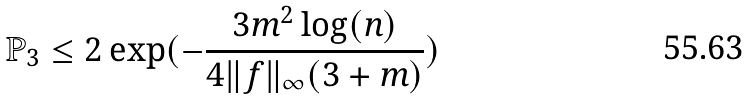Convert formula to latex. <formula><loc_0><loc_0><loc_500><loc_500>\mathbb { P } _ { 3 } \leq 2 \exp ( - \frac { 3 m ^ { 2 } \log ( n ) } { 4 \| f \| _ { \infty } ( 3 + m ) } )</formula> 